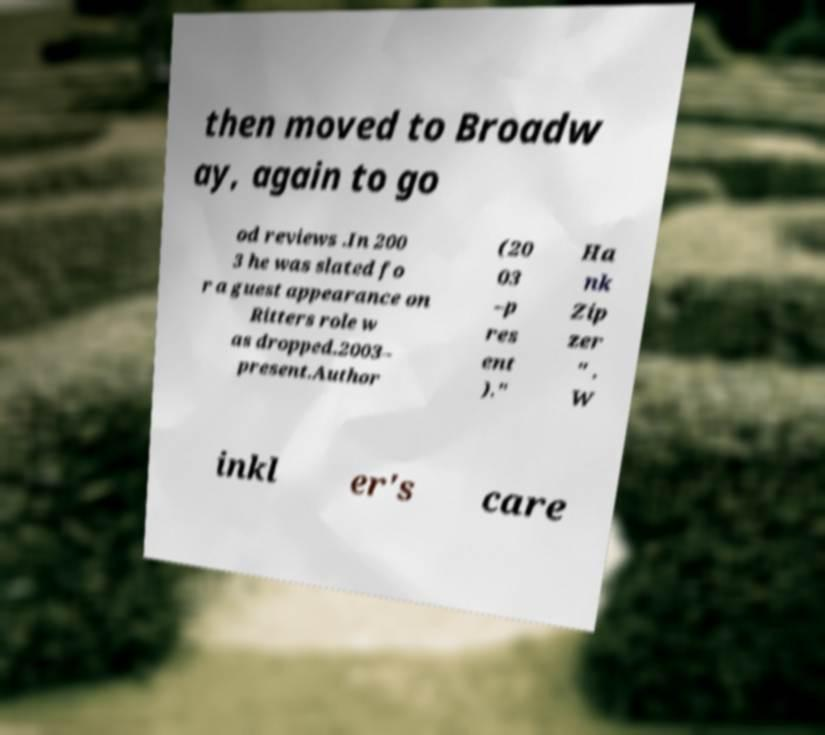I need the written content from this picture converted into text. Can you do that? then moved to Broadw ay, again to go od reviews .In 200 3 he was slated fo r a guest appearance on Ritters role w as dropped.2003– present.Author (20 03 –p res ent )." Ha nk Zip zer " . W inkl er's care 